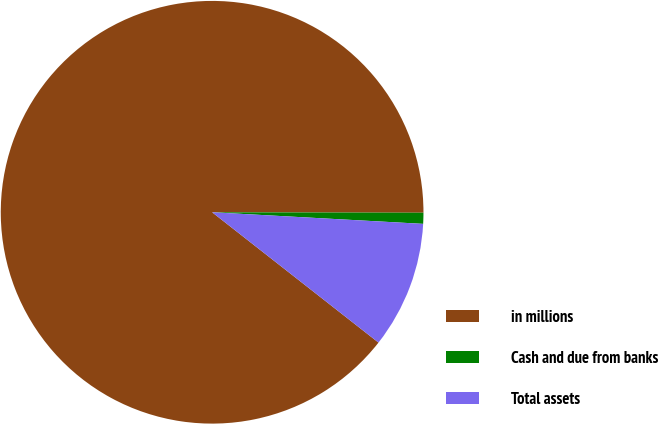<chart> <loc_0><loc_0><loc_500><loc_500><pie_chart><fcel>in millions<fcel>Cash and due from banks<fcel>Total assets<nl><fcel>89.45%<fcel>0.84%<fcel>9.7%<nl></chart> 